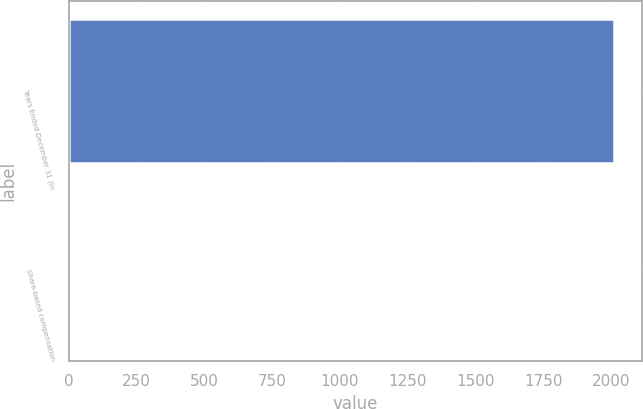Convert chart. <chart><loc_0><loc_0><loc_500><loc_500><bar_chart><fcel>Years Ended December 31 (in<fcel>Share-based compensation<nl><fcel>2011<fcel>10<nl></chart> 